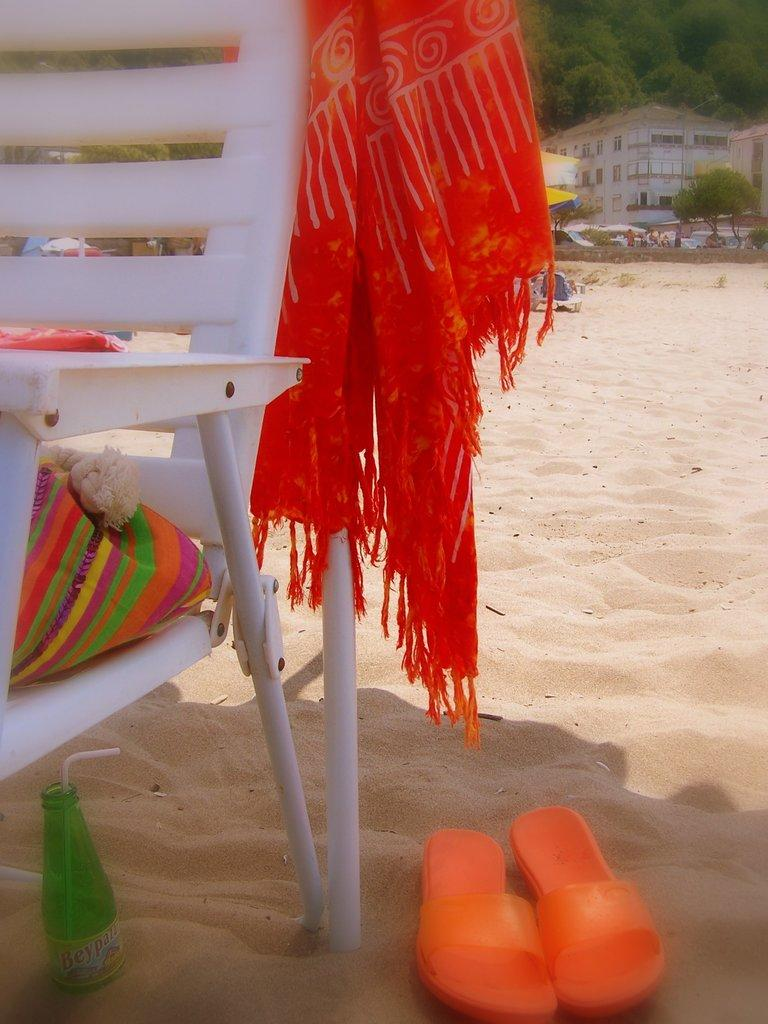What type of furniture is present in the image? There is a chair in the image. What type of surface is visible in the image? There is sand in the image. What object can be used for holding liquids? There is a bottle in the image. What type of footwear is present in the image? There are slippers in the image. What type of material is present in the image? There is cloth in the image. What can be seen in the background of the image? There are trees and a building in the background of the image. What type of throne is present in the image? There is no throne present in the image. What does the porter carry in the image? There is no porter present in the image. 